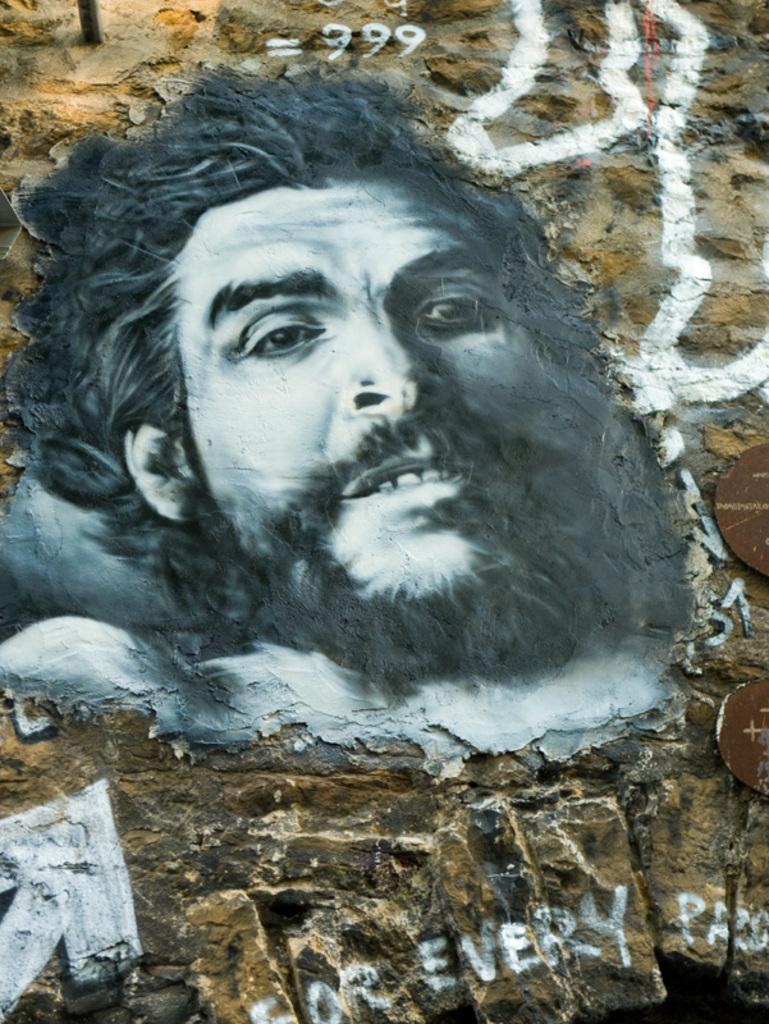What is the main structure visible in the image? There is a huge wall in the image. What material is the wall made of? The wall is made up of rocks. Is there any artwork on the wall? Yes, there is a painting on the wall. What is depicted in the painting? The painting is of a person's face. What colors are used in the painting? The painting is white and black in color. What type of musical instrument is being played in the image? There is no musical instrument or any indication of music being played in the image. 